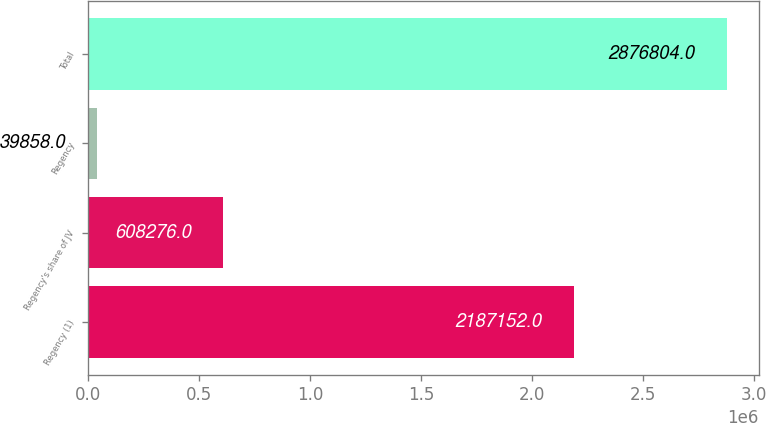Convert chart. <chart><loc_0><loc_0><loc_500><loc_500><bar_chart><fcel>Regency (1)<fcel>Regency's share of JV<fcel>Regency<fcel>Total<nl><fcel>2.18715e+06<fcel>608276<fcel>39858<fcel>2.8768e+06<nl></chart> 